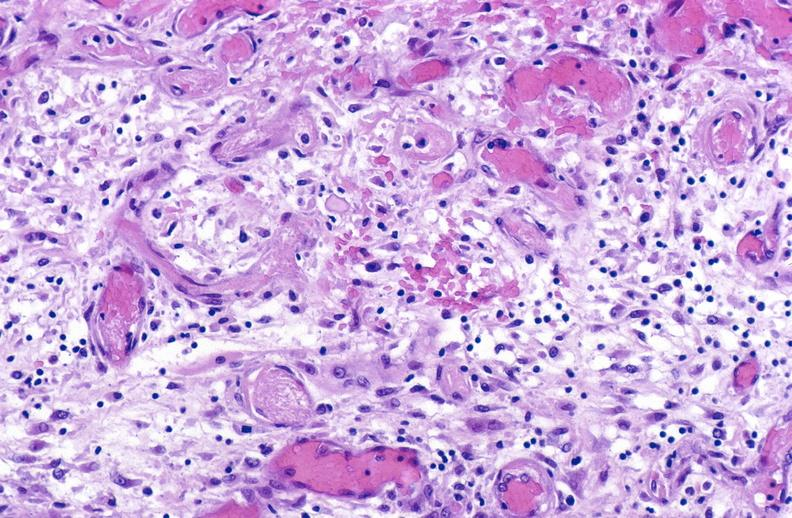s soft tissue present?
Answer the question using a single word or phrase. Yes 